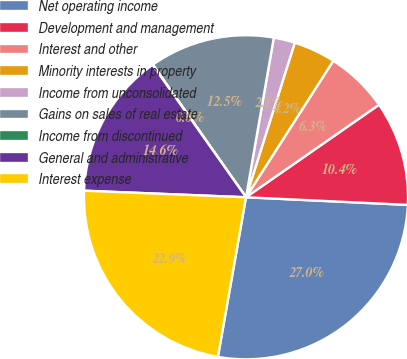Convert chart. <chart><loc_0><loc_0><loc_500><loc_500><pie_chart><fcel>Net operating income<fcel>Development and management<fcel>Interest and other<fcel>Minority interests in property<fcel>Income from unconsolidated<fcel>Gains on sales of real estate<fcel>Income from discontinued<fcel>General and administrative<fcel>Interest expense<nl><fcel>27.02%<fcel>10.42%<fcel>6.27%<fcel>4.19%<fcel>2.12%<fcel>12.49%<fcel>0.04%<fcel>14.57%<fcel>22.87%<nl></chart> 